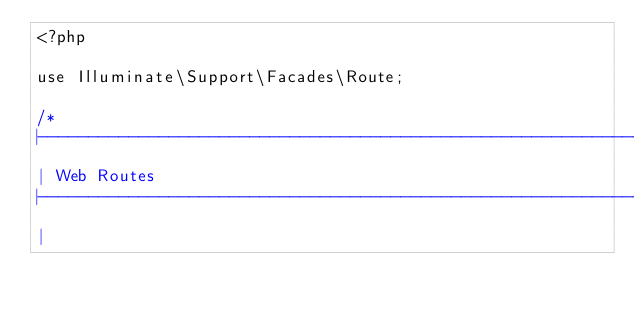Convert code to text. <code><loc_0><loc_0><loc_500><loc_500><_PHP_><?php

use Illuminate\Support\Facades\Route;

/*
|--------------------------------------------------------------------------
| Web Routes
|--------------------------------------------------------------------------
|</code> 